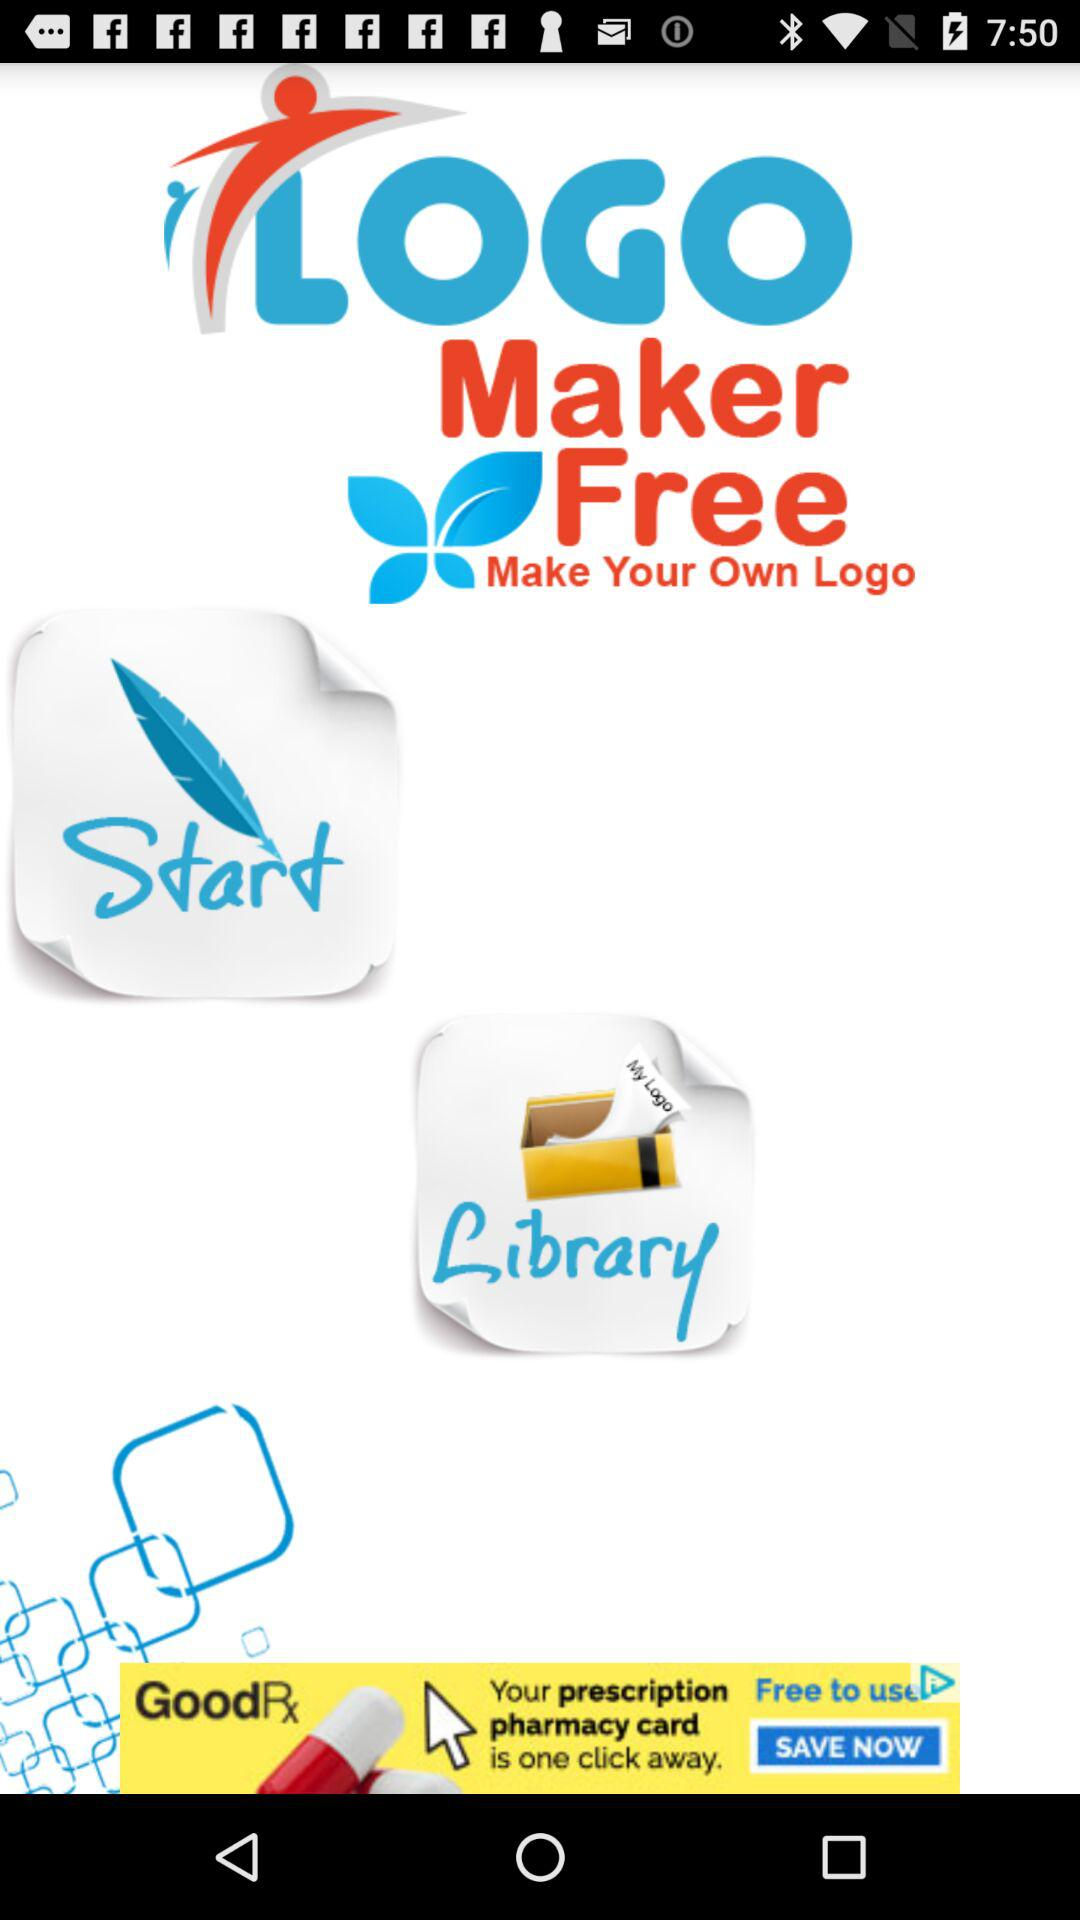Who is this application powered by?
When the provided information is insufficient, respond with <no answer>. <no answer> 